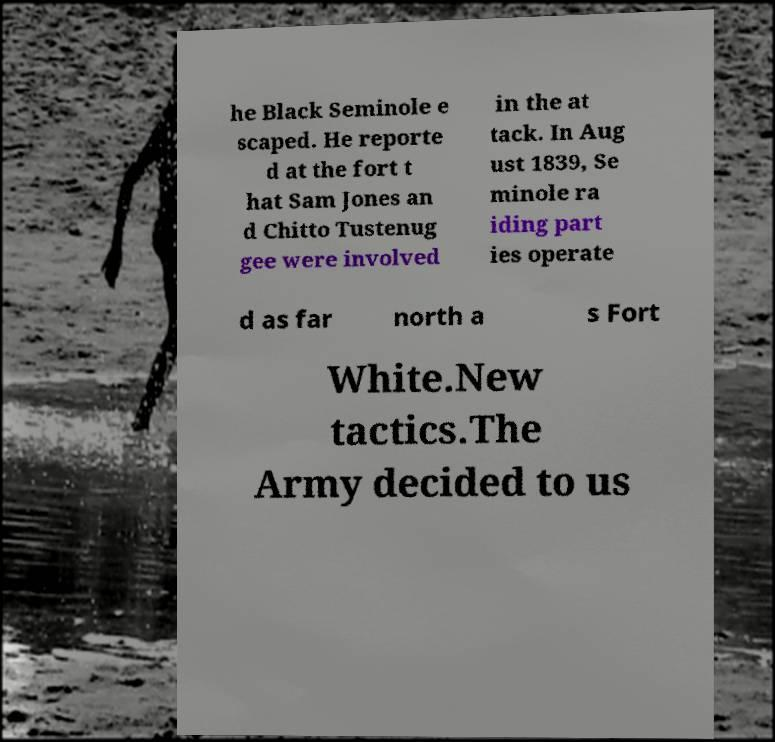I need the written content from this picture converted into text. Can you do that? he Black Seminole e scaped. He reporte d at the fort t hat Sam Jones an d Chitto Tustenug gee were involved in the at tack. In Aug ust 1839, Se minole ra iding part ies operate d as far north a s Fort White.New tactics.The Army decided to us 